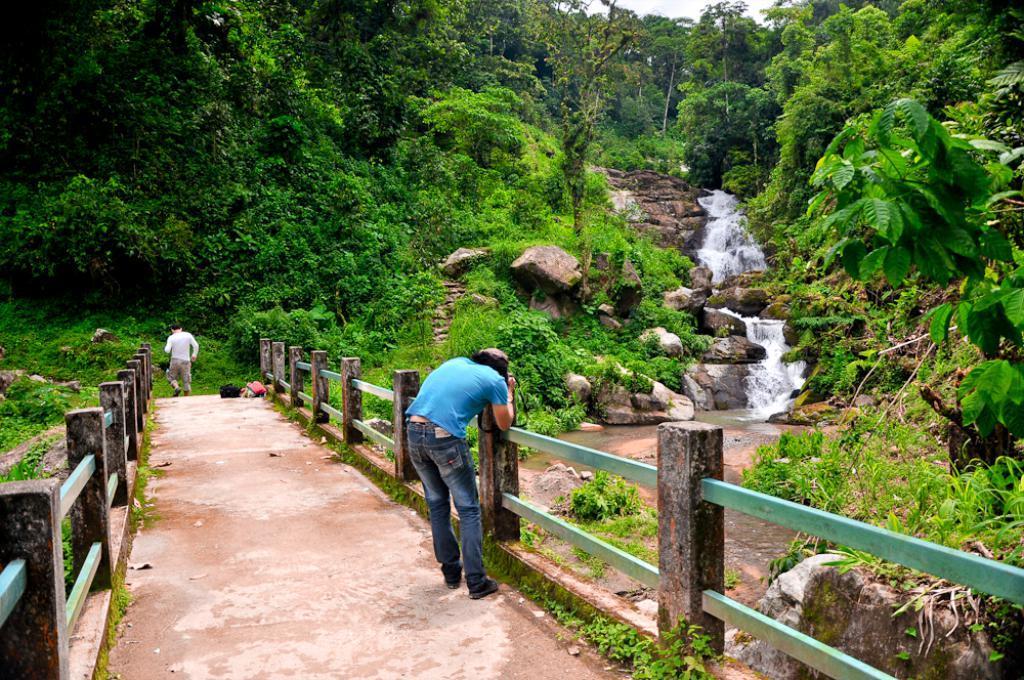Could you give a brief overview of what you see in this image? In this image we can see two persons, among them one person is holding an object, there are some trees, plants, water, grass, stone and the fence, also we can see the sky. 